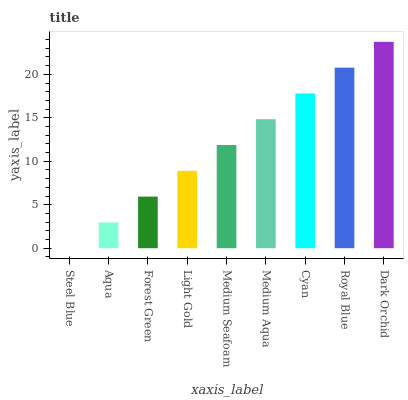Is Steel Blue the minimum?
Answer yes or no. Yes. Is Dark Orchid the maximum?
Answer yes or no. Yes. Is Aqua the minimum?
Answer yes or no. No. Is Aqua the maximum?
Answer yes or no. No. Is Aqua greater than Steel Blue?
Answer yes or no. Yes. Is Steel Blue less than Aqua?
Answer yes or no. Yes. Is Steel Blue greater than Aqua?
Answer yes or no. No. Is Aqua less than Steel Blue?
Answer yes or no. No. Is Medium Seafoam the high median?
Answer yes or no. Yes. Is Medium Seafoam the low median?
Answer yes or no. Yes. Is Medium Aqua the high median?
Answer yes or no. No. Is Cyan the low median?
Answer yes or no. No. 